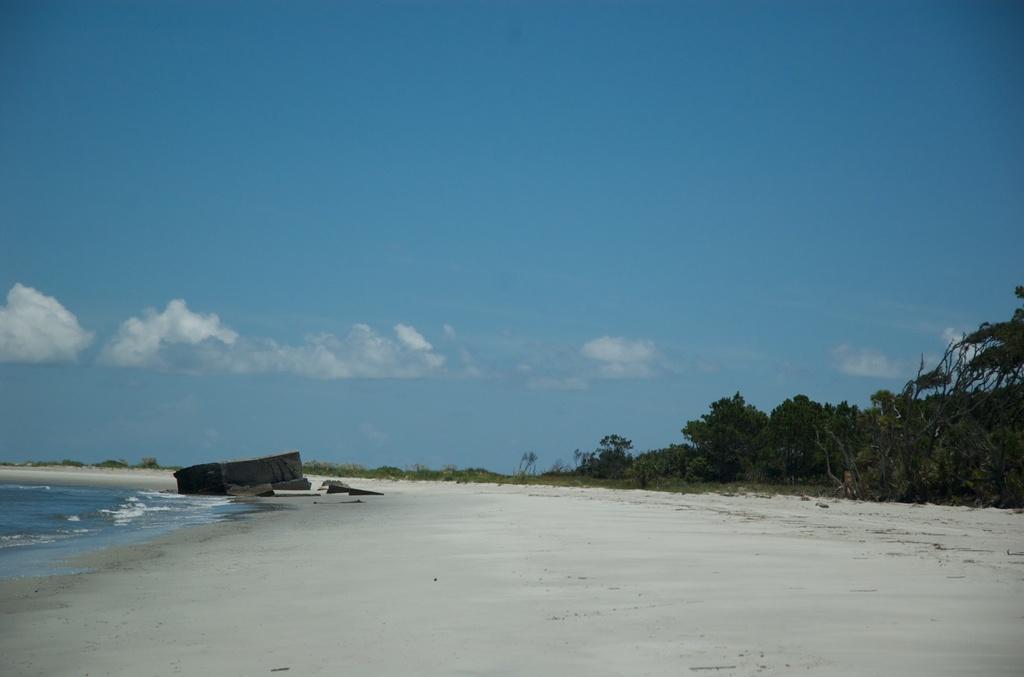How would you summarize this image in a sentence or two? In this picture I can observe a beach. On the left side there is an ocean. On the right side I can observe some trees. In the background there are some clouds in the sky. 